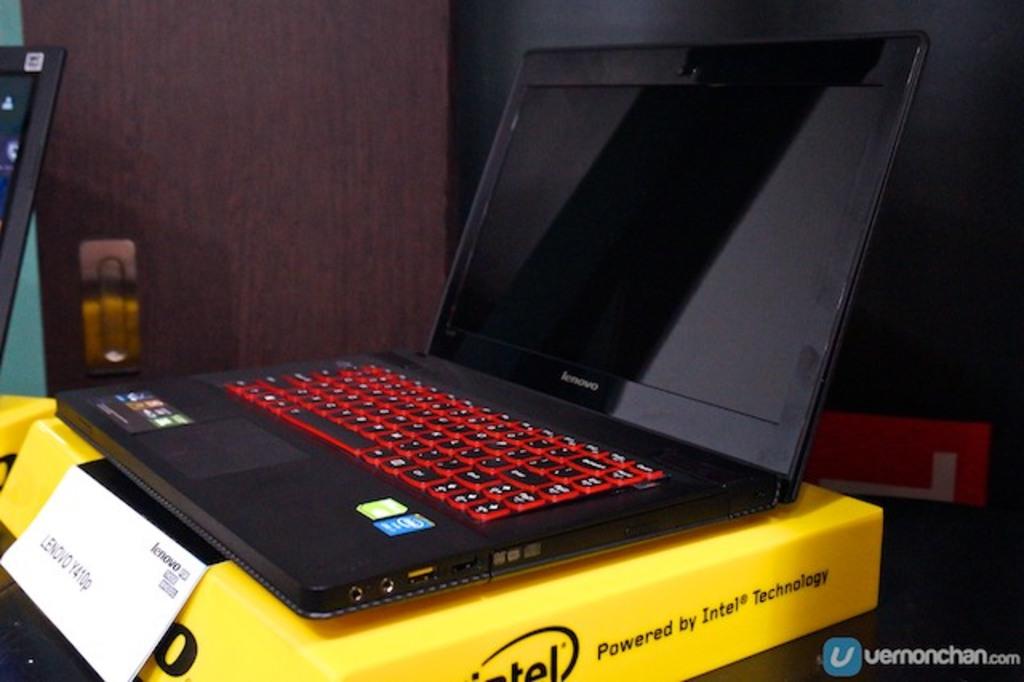What is this computer powered by?
Offer a very short reply. Intel. What brand is listed on the white card?
Provide a short and direct response. Lenovo. 